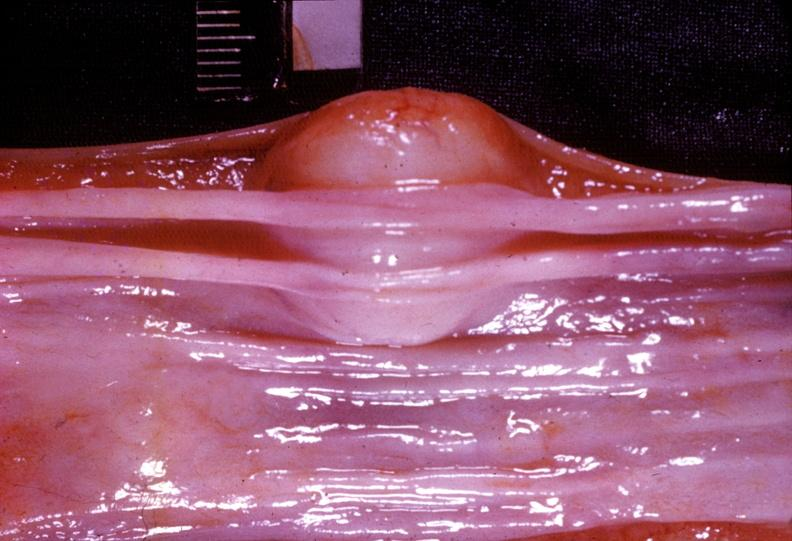does carcinoma show esophagus, leiomyoma?
Answer the question using a single word or phrase. No 